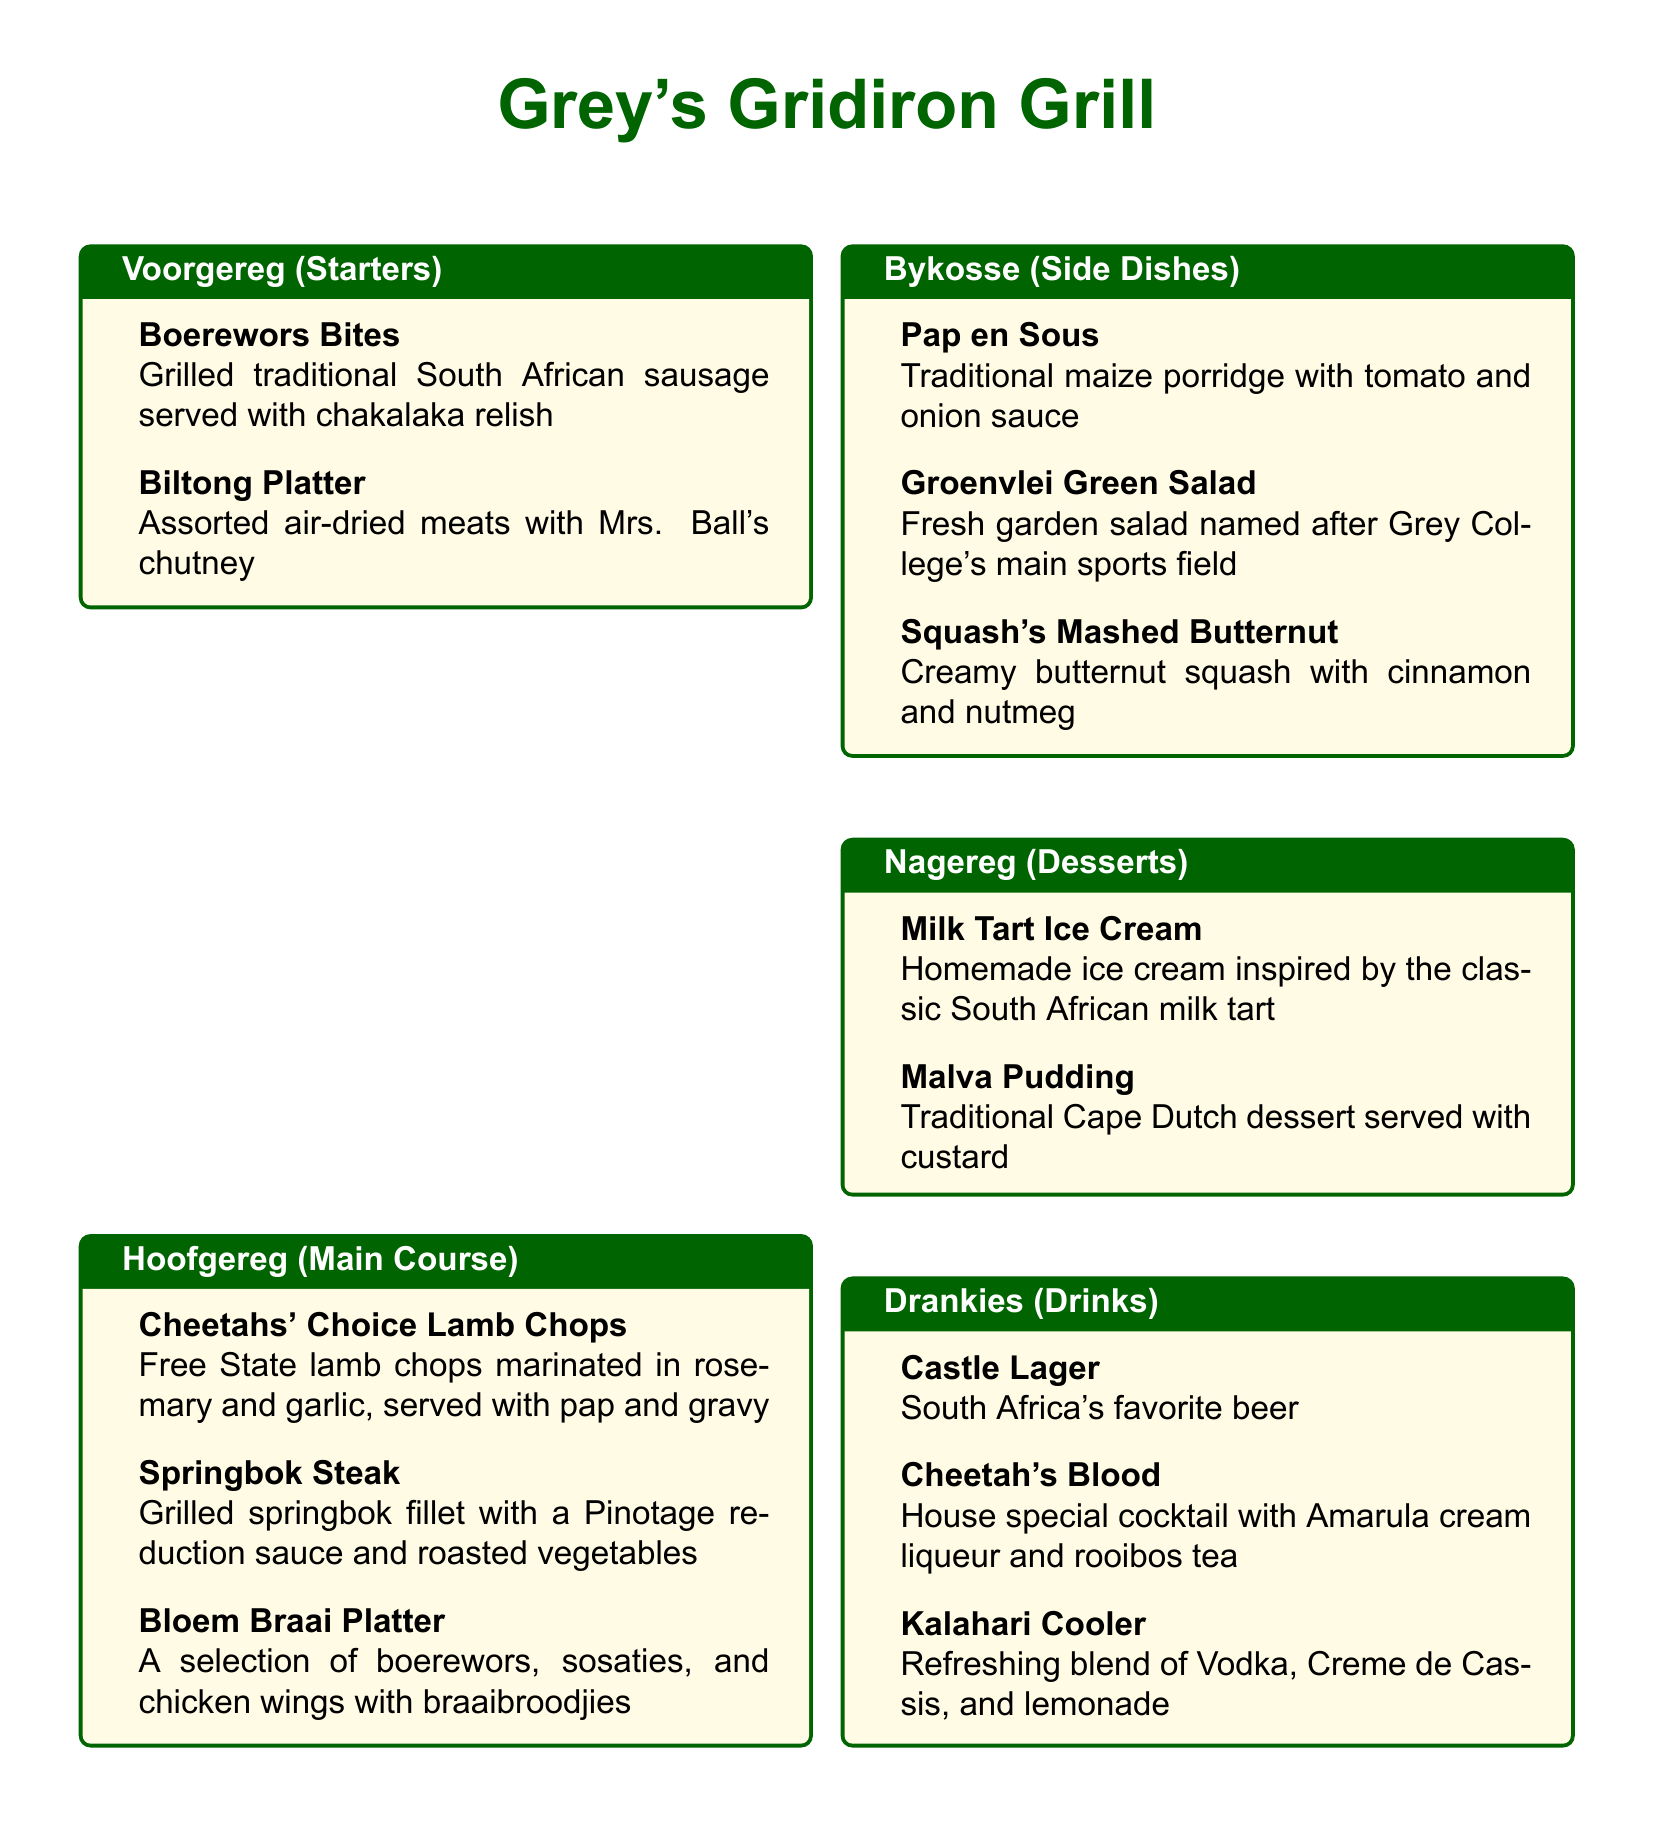What is the name of the restaurant? The name of the restaurant is prominently displayed at the top of the menu.
Answer: Grey's Gridiron Grill What type of cuisine is featured in the menu? The menu showcases traditional South African grilled meats and sides.
Answer: Braai-style How many starters are listed in the menu? Counting the items in the Voorgereg (Starters) section reveals the total.
Answer: 2 What dish includes boerewors? The dish that features boerewors is listed under the main course section.
Answer: Bloem Braai Platter Which drink is referred to as South Africa's favorite beer? This information is stated in the Drankies (Drinks) section.
Answer: Castle Lager What is the main protein in the Springbok Steak? The menu specifies the type of meat used for this dish clearly.
Answer: Springbok Which side dish features creamy butternut? The specific side dish with creamy butternut is found in the Bykosse section.
Answer: Squash's Mashed Butternut What dessert is inspired by a classic South African dish? The dessert is a variation of a well-known traditional sweet.
Answer: Milk Tart Ice Cream What is served with the Cheetahs' Choice Lamb Chops? The main course item includes a side traditionally paired with lamb.
Answer: Pap and gravy 